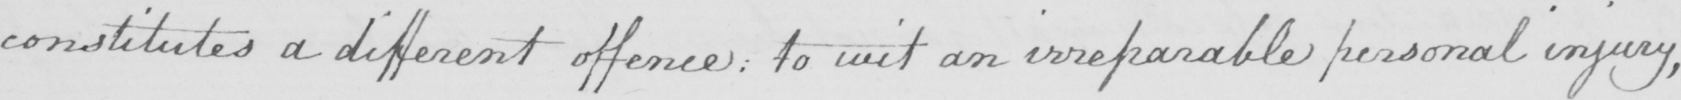Transcribe the text shown in this historical manuscript line. constitutes a different offence :  to wit an irreparable personal injury , 